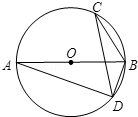Can you explain why angle ADB is a right angle? Certainly! In the given circle, AB is a diameter. Any angle inscribed in a semicircle, like angle ADB, forms a right angle. This is a well-known theorem in geometry known as the Thales' theorem, which states that if the diameter of the circle subtends a chord, then the angle opposite the chord (thus subtending the diameter) is a right angle. 